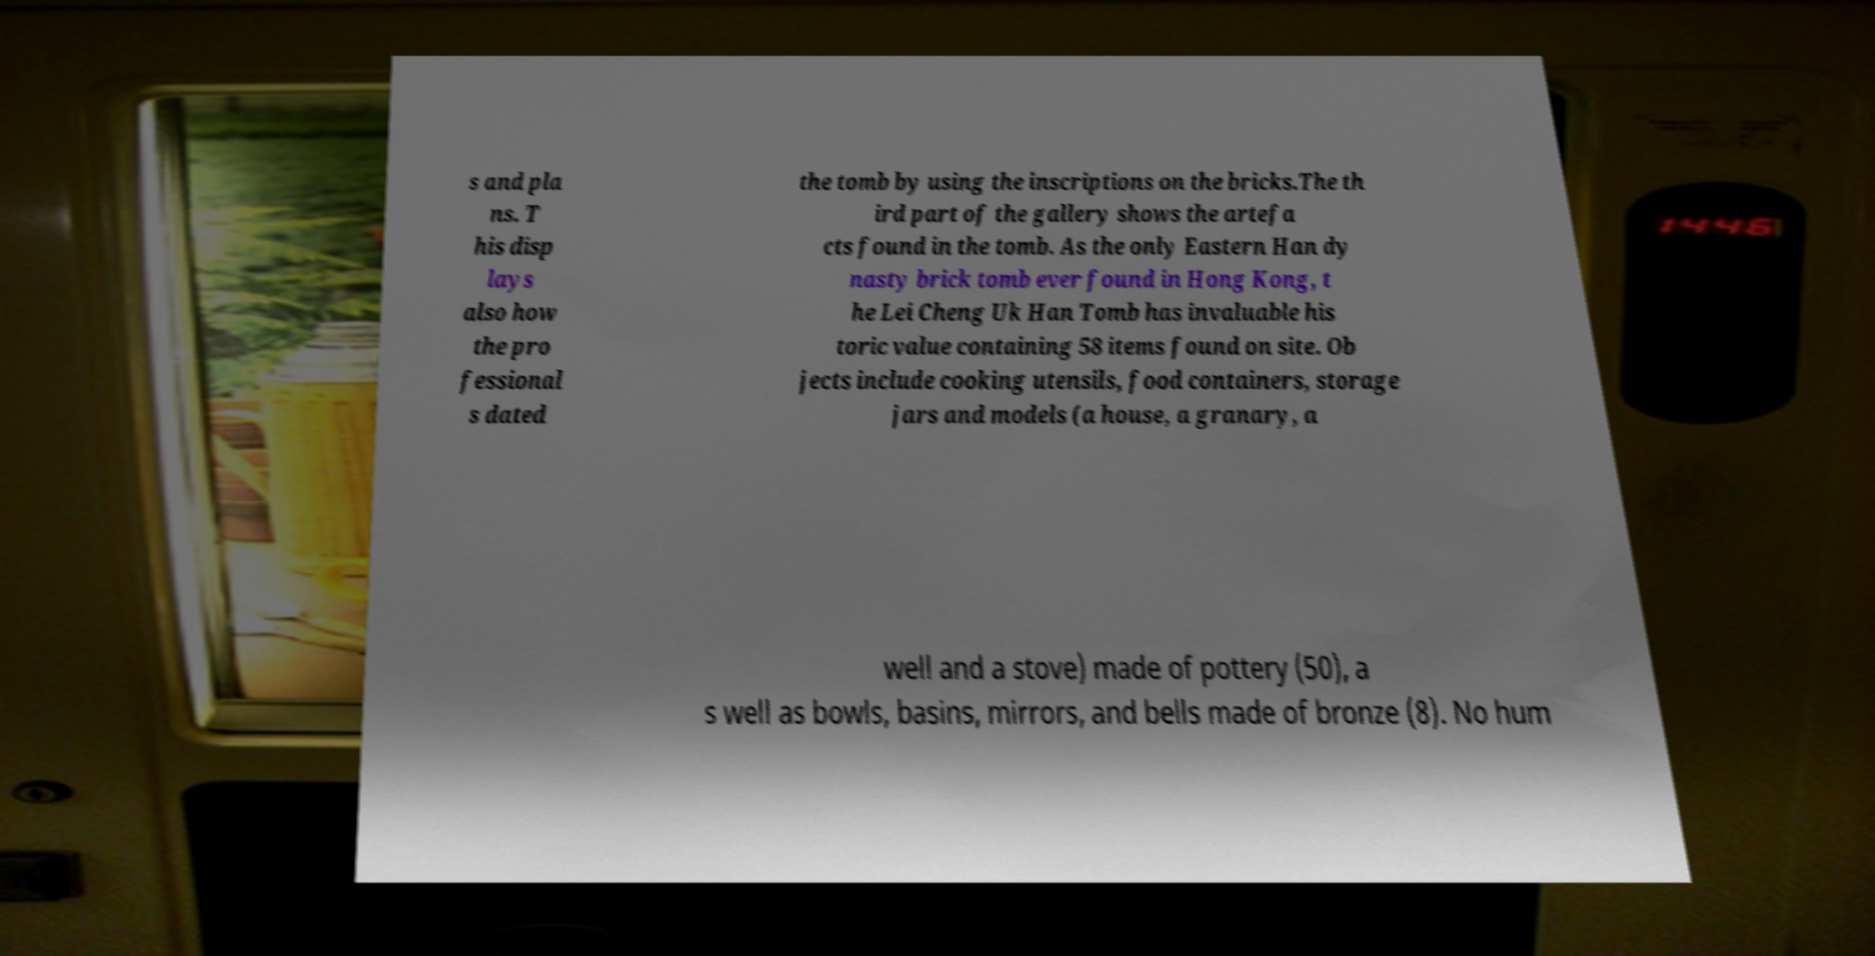Please read and relay the text visible in this image. What does it say? s and pla ns. T his disp lays also how the pro fessional s dated the tomb by using the inscriptions on the bricks.The th ird part of the gallery shows the artefa cts found in the tomb. As the only Eastern Han dy nasty brick tomb ever found in Hong Kong, t he Lei Cheng Uk Han Tomb has invaluable his toric value containing 58 items found on site. Ob jects include cooking utensils, food containers, storage jars and models (a house, a granary, a well and a stove) made of pottery (50), a s well as bowls, basins, mirrors, and bells made of bronze (8). No hum 